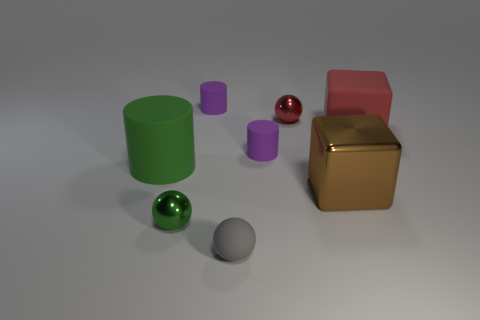Add 1 blue metallic blocks. How many objects exist? 9 Subtract all cylinders. How many objects are left? 5 Add 1 small purple things. How many small purple things exist? 3 Subtract 0 red cylinders. How many objects are left? 8 Subtract all big rubber blocks. Subtract all green rubber objects. How many objects are left? 6 Add 2 red rubber cubes. How many red rubber cubes are left? 3 